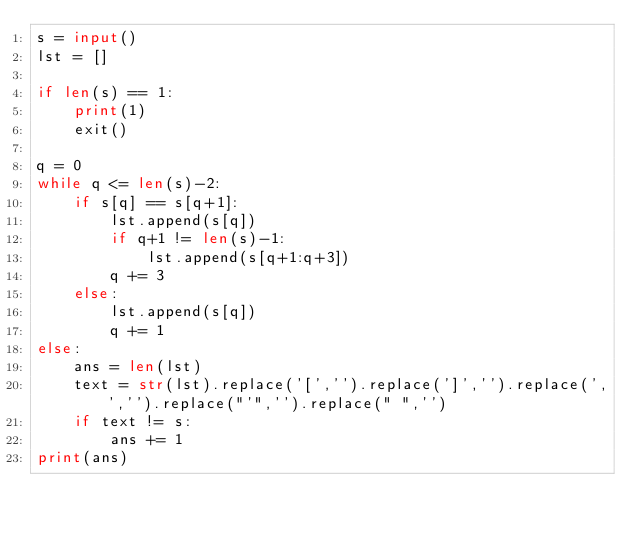<code> <loc_0><loc_0><loc_500><loc_500><_Python_>s = input()
lst = []

if len(s) == 1:
    print(1)
    exit()

q = 0
while q <= len(s)-2:
    if s[q] == s[q+1]:
        lst.append(s[q])
        if q+1 != len(s)-1:
            lst.append(s[q+1:q+3])
        q += 3
    else:
        lst.append(s[q])
        q += 1
else:
    ans = len(lst)
    text = str(lst).replace('[','').replace(']','').replace(',','').replace("'",'').replace(" ",'')
    if text != s:
        ans += 1
print(ans)</code> 